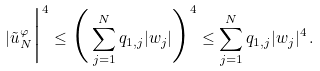Convert formula to latex. <formula><loc_0><loc_0><loc_500><loc_500>| \tilde { u } _ { N } ^ { \varphi } \Big | ^ { 4 } \leq \Big ( \sum _ { j = 1 } ^ { N } q _ { 1 , j } | w _ { j } | \Big ) ^ { 4 } \leq \sum _ { j = 1 } ^ { N } q _ { 1 , j } | w _ { j } | ^ { 4 } \, .</formula> 